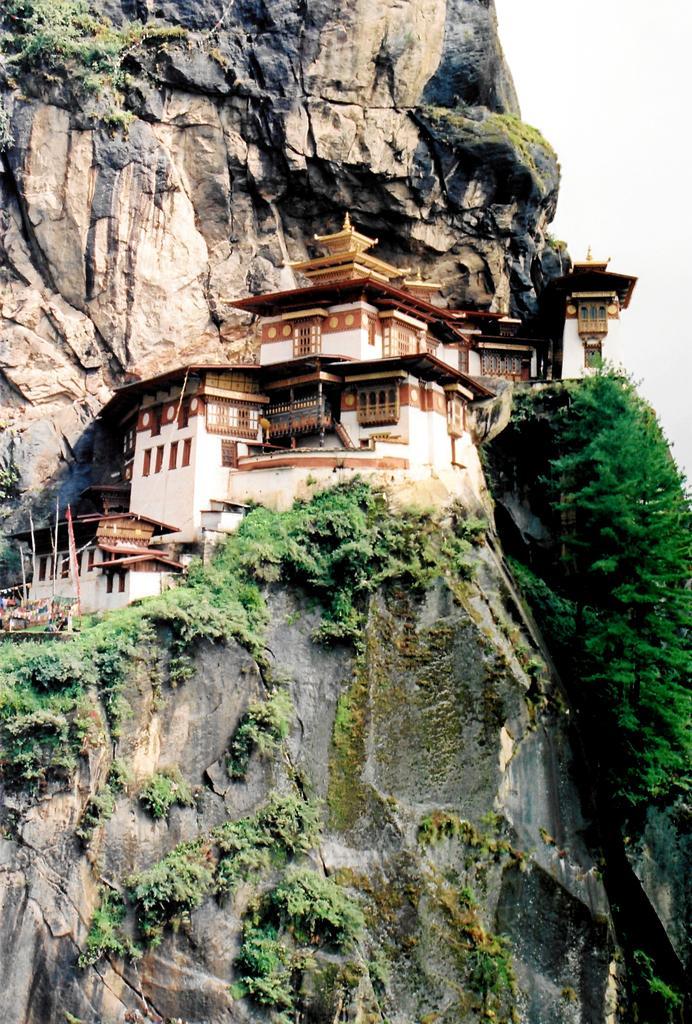How would you summarize this image in a sentence or two? This picture is clicked outside. In the center we can see the houses and the windows of the houses. On the right we can see the plants. In the background we can see the sky and we can see the rocks. 